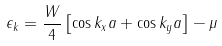Convert formula to latex. <formula><loc_0><loc_0><loc_500><loc_500>\epsilon _ { k } = \frac { W } { 4 } \left [ \cos k _ { x } a + \cos k _ { y } a \right ] - \mu</formula> 